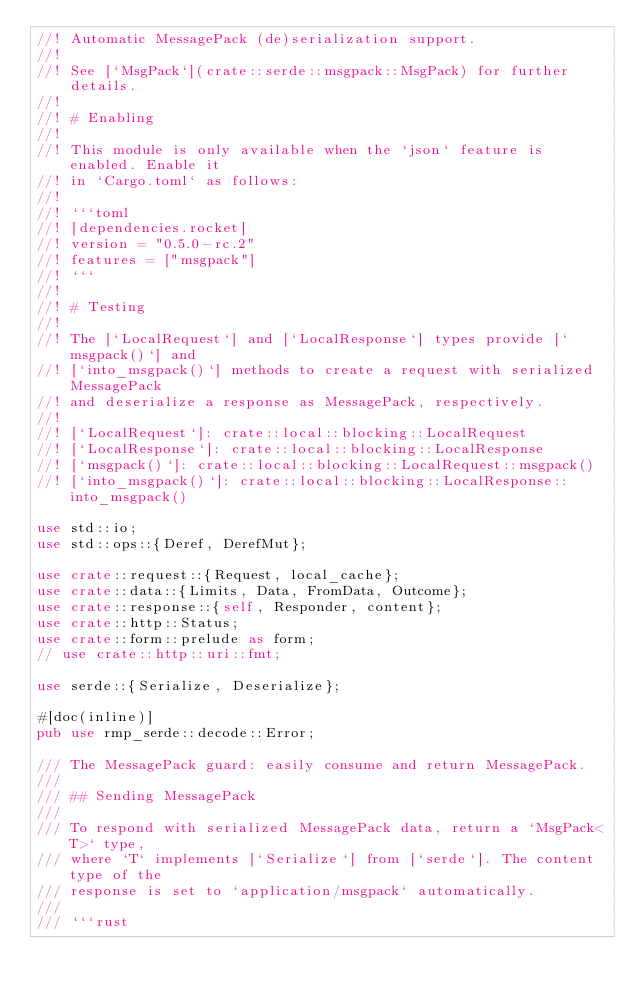Convert code to text. <code><loc_0><loc_0><loc_500><loc_500><_Rust_>//! Automatic MessagePack (de)serialization support.
//!
//! See [`MsgPack`](crate::serde::msgpack::MsgPack) for further details.
//!
//! # Enabling
//!
//! This module is only available when the `json` feature is enabled. Enable it
//! in `Cargo.toml` as follows:
//!
//! ```toml
//! [dependencies.rocket]
//! version = "0.5.0-rc.2"
//! features = ["msgpack"]
//! ```
//!
//! # Testing
//!
//! The [`LocalRequest`] and [`LocalResponse`] types provide [`msgpack()`] and
//! [`into_msgpack()`] methods to create a request with serialized MessagePack
//! and deserialize a response as MessagePack, respectively.
//!
//! [`LocalRequest`]: crate::local::blocking::LocalRequest
//! [`LocalResponse`]: crate::local::blocking::LocalResponse
//! [`msgpack()`]: crate::local::blocking::LocalRequest::msgpack()
//! [`into_msgpack()`]: crate::local::blocking::LocalResponse::into_msgpack()

use std::io;
use std::ops::{Deref, DerefMut};

use crate::request::{Request, local_cache};
use crate::data::{Limits, Data, FromData, Outcome};
use crate::response::{self, Responder, content};
use crate::http::Status;
use crate::form::prelude as form;
// use crate::http::uri::fmt;

use serde::{Serialize, Deserialize};

#[doc(inline)]
pub use rmp_serde::decode::Error;

/// The MessagePack guard: easily consume and return MessagePack.
///
/// ## Sending MessagePack
///
/// To respond with serialized MessagePack data, return a `MsgPack<T>` type,
/// where `T` implements [`Serialize`] from [`serde`]. The content type of the
/// response is set to `application/msgpack` automatically.
///
/// ```rust</code> 